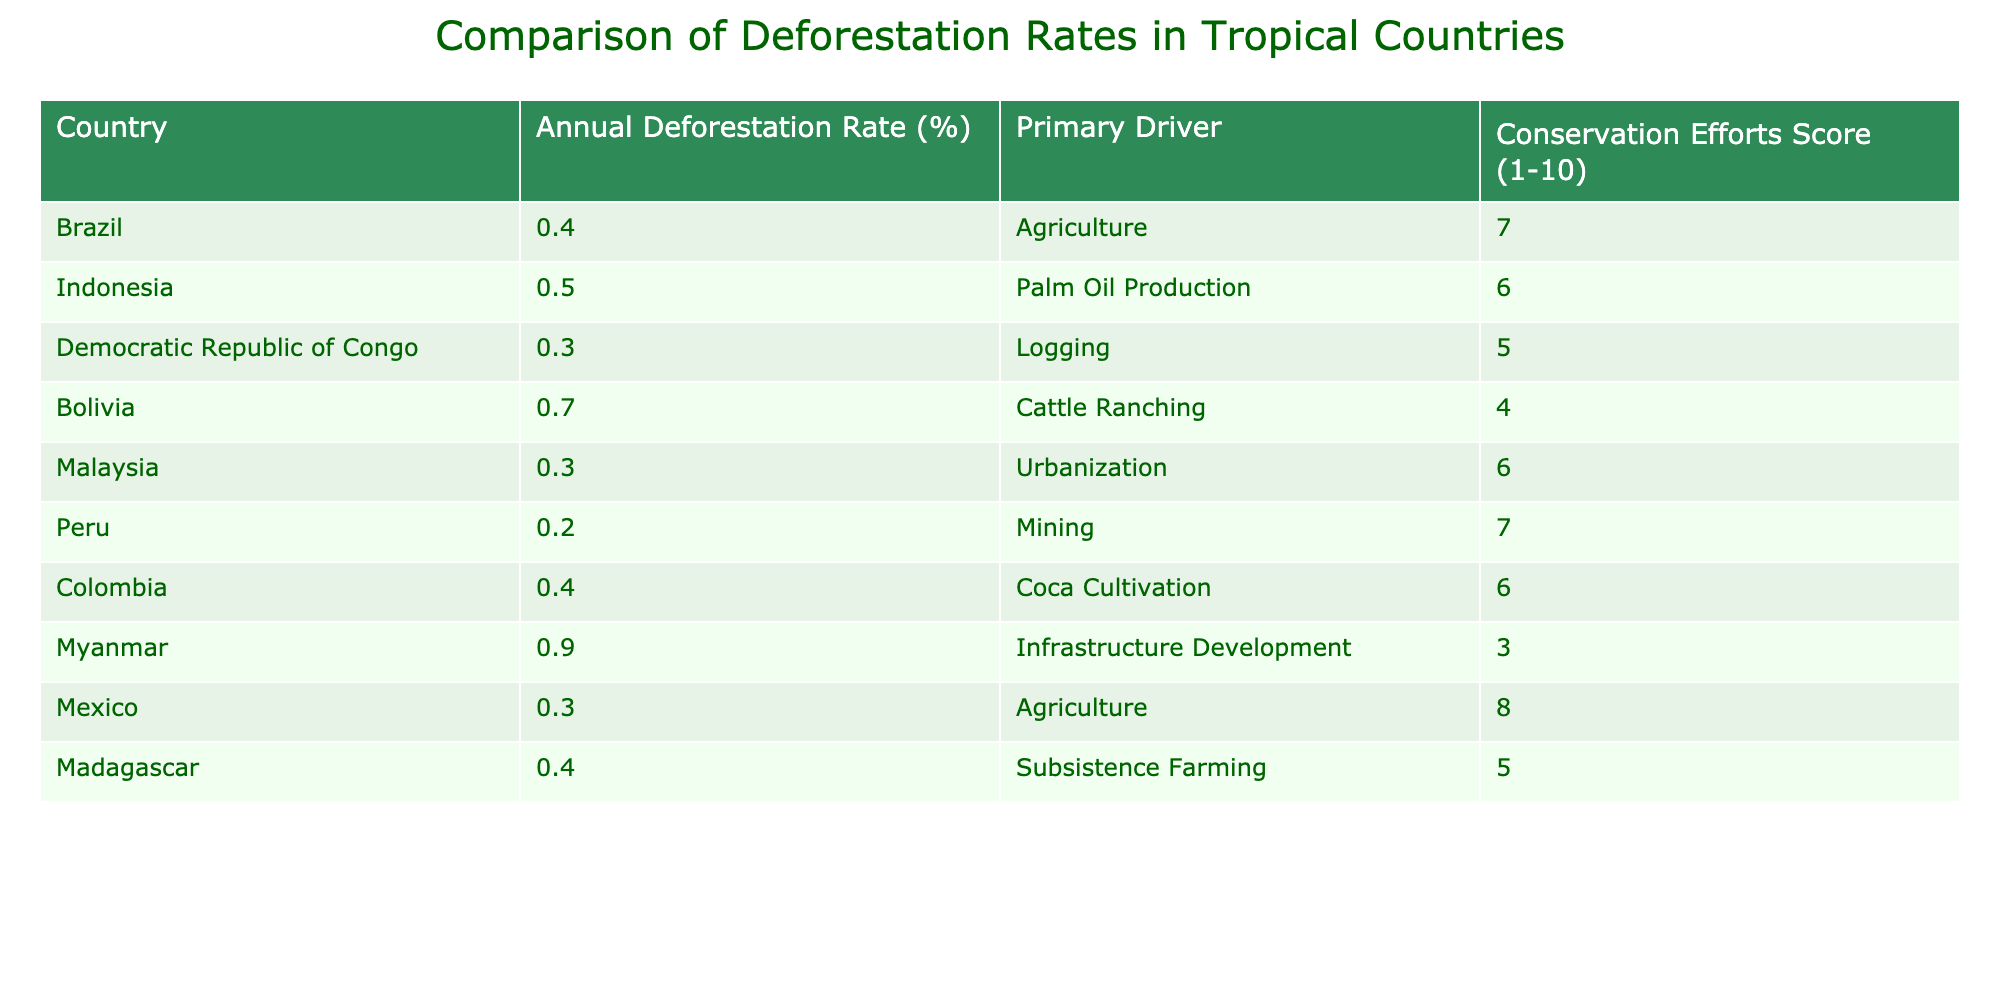What is the annual deforestation rate in Brazil? The table shows Brazil's annual deforestation rate as 0.4%.
Answer: 0.4% Which country has the highest deforestation rate? By comparing the annual deforestation rates in the table, Myanmar has the highest rate at 0.9%.
Answer: Myanmar What is the primary driver of deforestation in Colombia? The table indicates that the primary driver of deforestation in Colombia is coca cultivation.
Answer: Coca cultivation What country has the lowest annual deforestation rate and what is the rate? Peru has the lowest annual deforestation rate listed in the table at 0.2%.
Answer: Peru, 0.2% Is it true that Madagascar has a higher deforestation rate than the Democratic Republic of Congo? The table shows Madagascar's rate as 0.4% and the Democratic Republic of Congo's rate as 0.3%. Therefore, the statement is true.
Answer: True What is the average annual deforestation rate of the countries listed in this table? Adding the annual deforestation rates together: 0.4 + 0.5 + 0.3 + 0.7 + 0.3 + 0.2 + 0.4 + 0.9 + 0.3 + 0.4 = 3.6. There are 10 countries, so the average is 3.6 / 10 = 0.36%.
Answer: 0.36% Which two countries have similar deforestation rates of 0.4%? The table lists both Brazil and Colombia with the same deforestation rate of 0.4%.
Answer: Brazil and Colombia How does the Conservation Efforts Score correlate with the annual deforestation rate in Bolivia? Bolivia has a deforestation rate of 0.7% and a Conservation Efforts Score of 4, which is among the lower scores resulting in a higher rate of deforestation.
Answer: Correlation is negative What is the difference in deforestation rates between Indonesia and Malaysia? Indonesia has a deforestation rate of 0.5% and Malaysia has a rate of 0.3%, so the difference is 0.5 - 0.3 = 0.2%.
Answer: 0.2% How many countries have a Conservation Efforts Score of 6 or higher? The table lists countries with scores of 6 or higher as Brazil, Peru, Mexico, and Colombia, totaling 4 countries.
Answer: 4 countries 